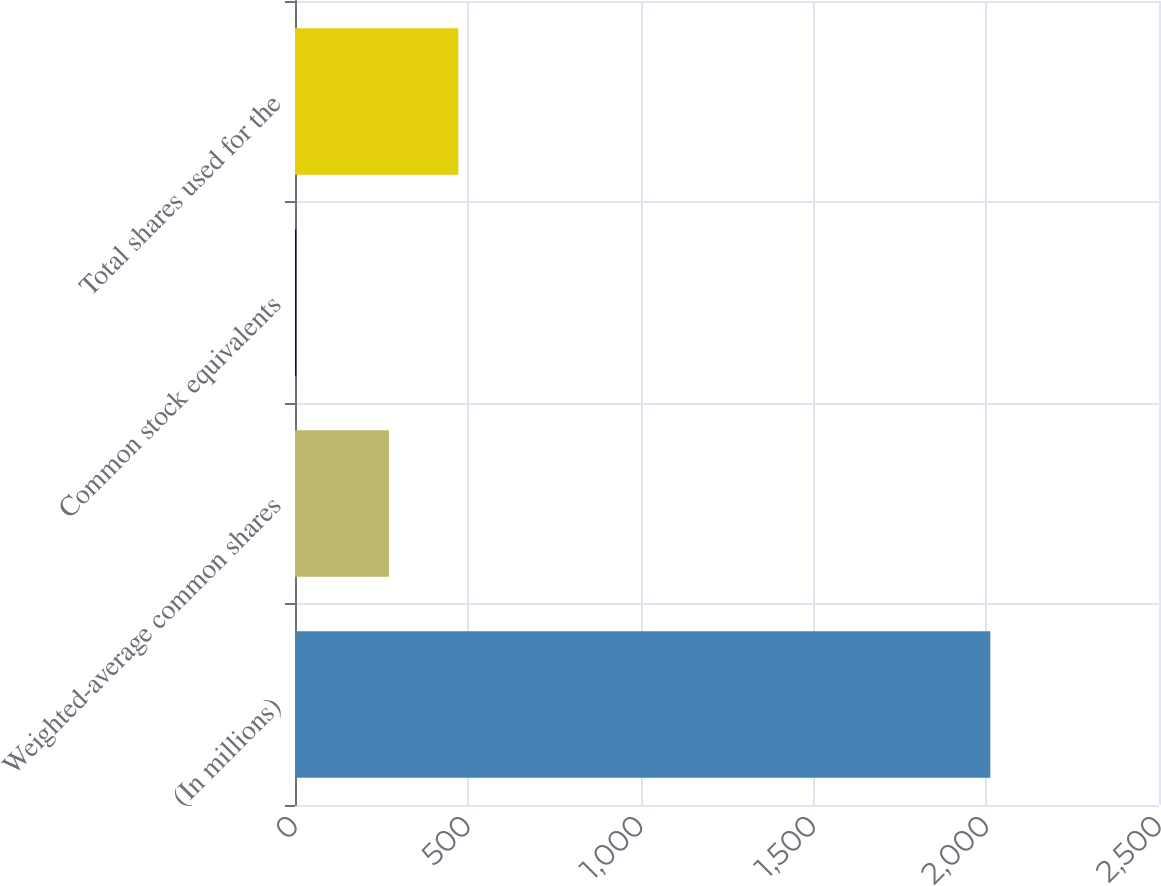Convert chart. <chart><loc_0><loc_0><loc_500><loc_500><bar_chart><fcel>(In millions)<fcel>Weighted-average common shares<fcel>Common stock equivalents<fcel>Total shares used for the<nl><fcel>2012<fcel>271.6<fcel>3.4<fcel>472.46<nl></chart> 